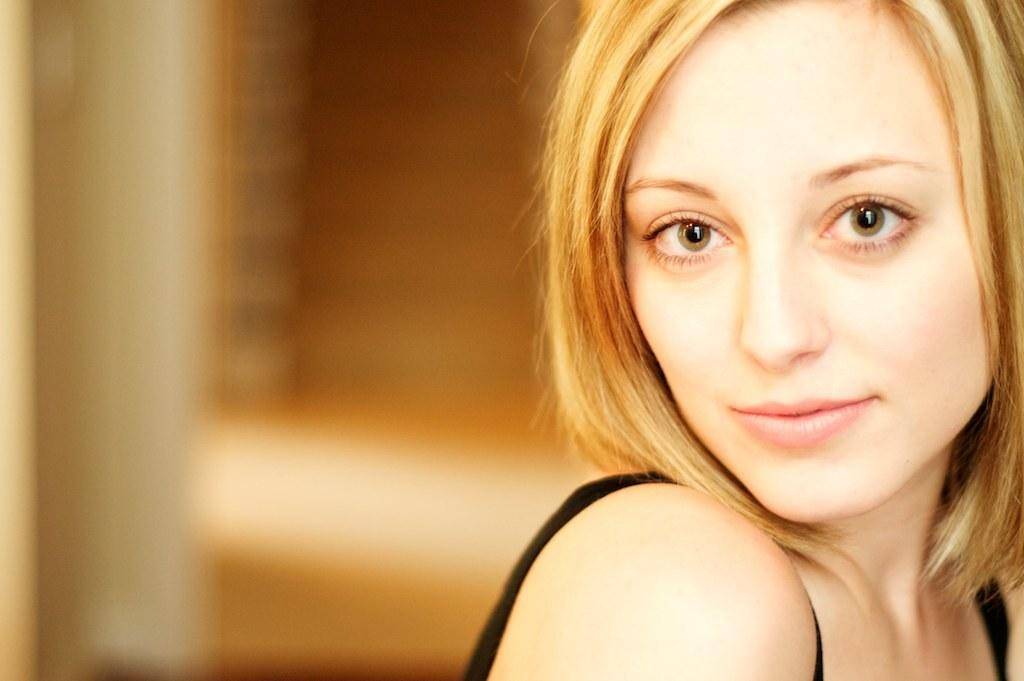Who is the main subject in the image? There is a woman in the image. Where is the woman located in the image? The woman is on the right side of the image. What is a noticeable feature of the woman's appearance? The woman has yellow hair. What is the woman's facial expression in the image? The woman is smiling. How would you describe the background of the image? The background of the image is blurred. What type of marble is being used to construct the harbor in the image? There is no harbor or marble present in the image; it features a woman with yellow hair who is smiling. 